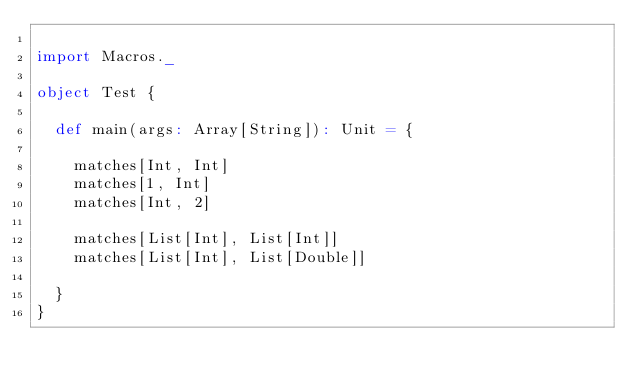Convert code to text. <code><loc_0><loc_0><loc_500><loc_500><_Scala_>
import Macros._

object Test {

  def main(args: Array[String]): Unit = {

    matches[Int, Int]
    matches[1, Int]
    matches[Int, 2]

    matches[List[Int], List[Int]]
    matches[List[Int], List[Double]]

  }
}

</code> 